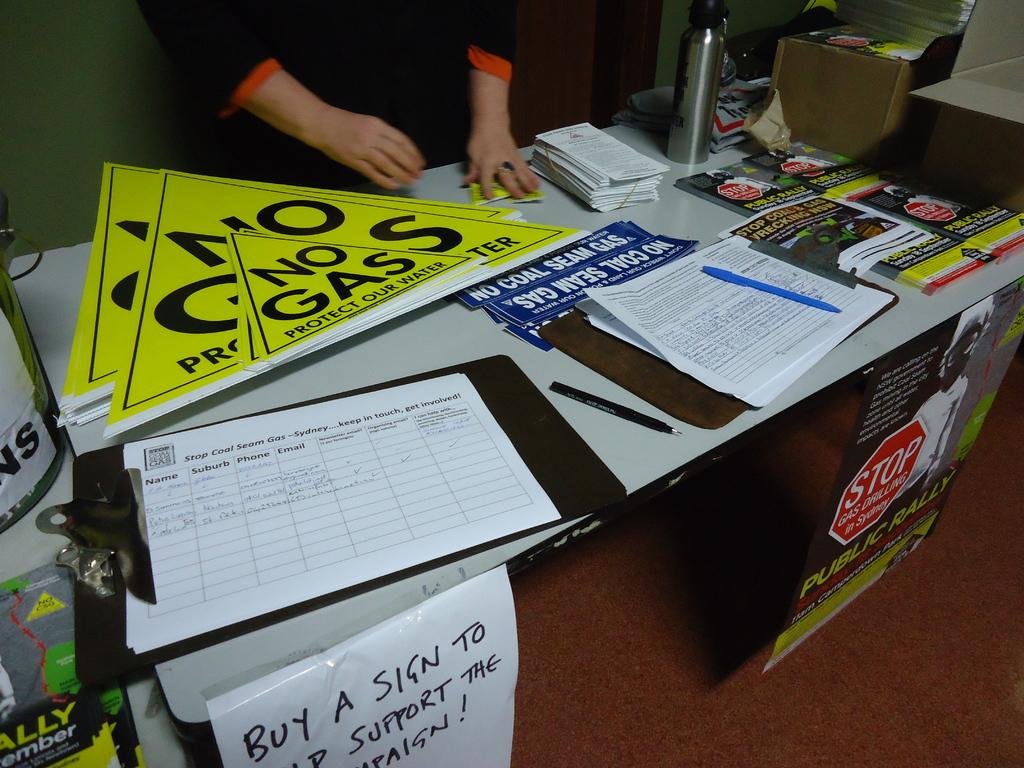What does the blue label say?
Offer a very short reply. No coal seam gas. 